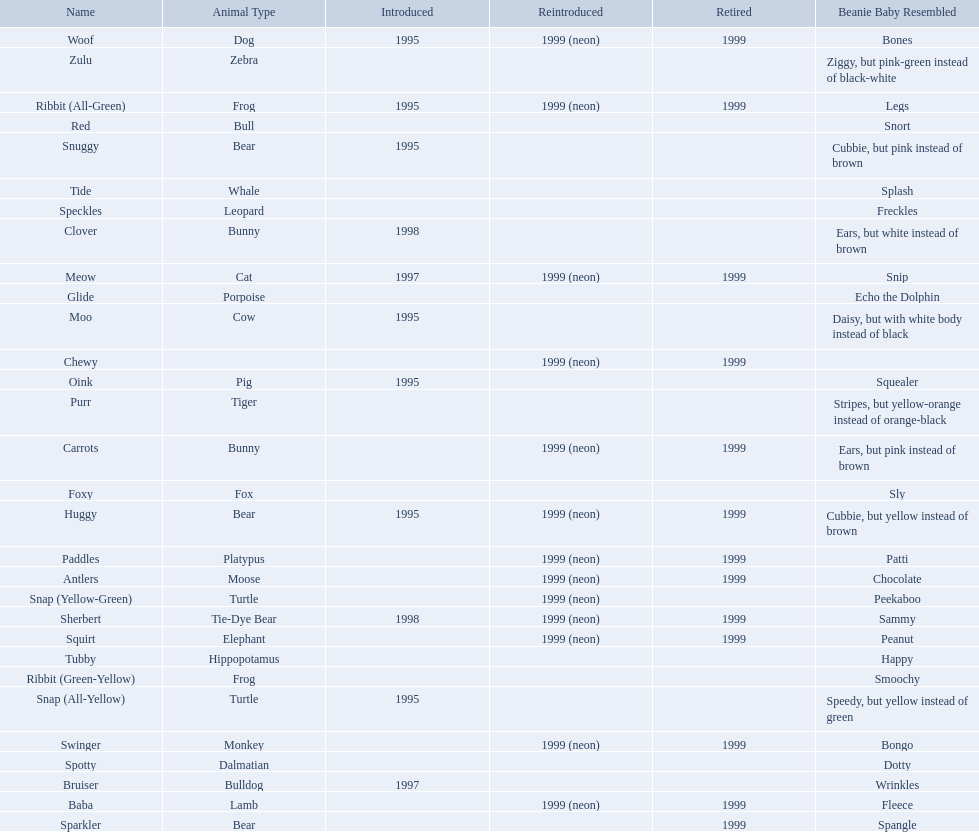Which of the listed pillow pals lack information in at least 3 categories? Chewy, Foxy, Glide, Purr, Red, Ribbit (Green-Yellow), Speckles, Spotty, Tide, Tubby, Zulu. Of those, which one lacks information in the animal type category? Chewy. 